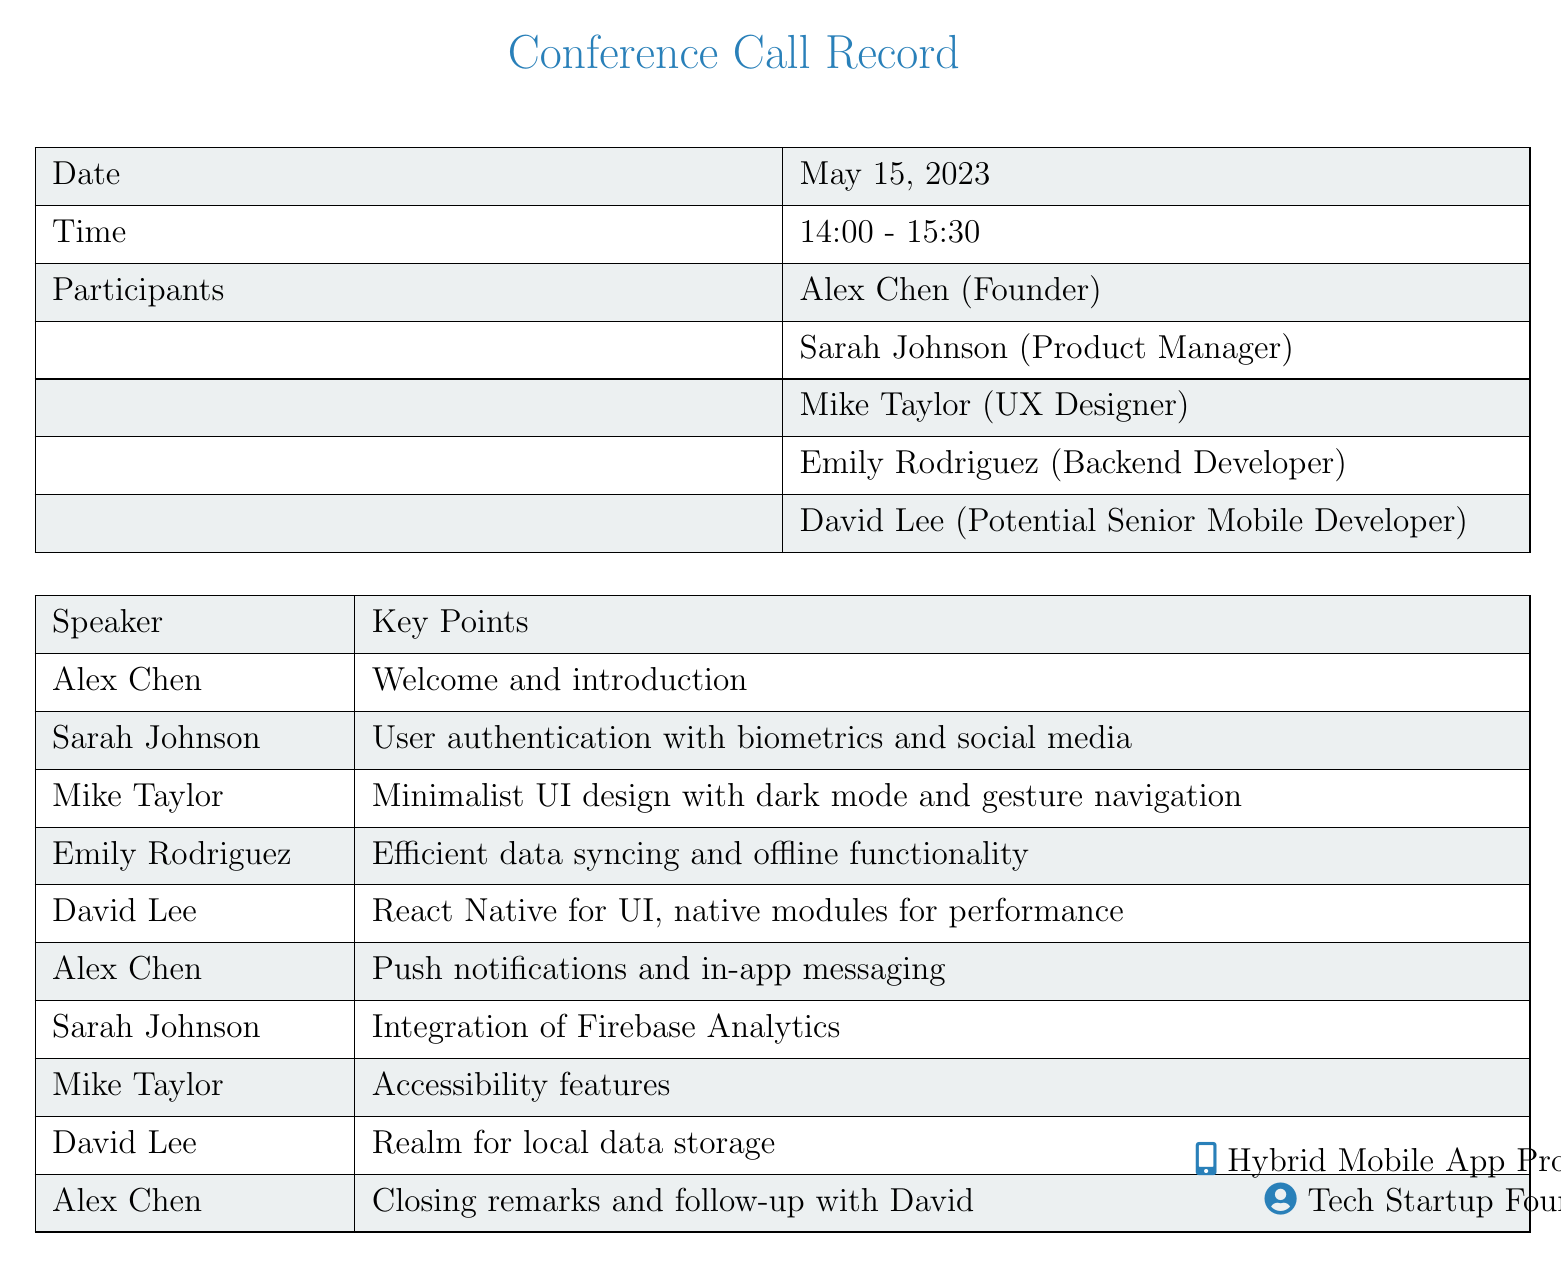What is the date of the conference call? The date is specified in the document as the date of the meeting.
Answer: May 15, 2023 Who is the Product Manager? The document lists the participants, identifying their roles, including the Product Manager.
Answer: Sarah Johnson What feature did Sarah Johnson suggest? The document includes key points made by participants, indicating features discussed during the call.
Answer: User authentication with biometrics and social media What technology did David Lee recommend for UI development? The document states David Lee's input on technology to be used, particularly for UI.
Answer: React Native What was mentioned for local data storage? One of the key points includes a specific technology recommended for local data.
Answer: Realm Who provided the closing remarks? The document indicates who concluded the discussion during the call.
Answer: Alex Chen What time did the conference call start? The starting time of the conference call is indicated in the document.
Answer: 14:00 Which participant is a Potential Senior Mobile Developer? The document identifies participants along with their roles.
Answer: David Lee What functionality did Emily Rodriguez emphasize? The key points in the document include a suggestion made by Emily Rodriguez.
Answer: Efficient data syncing and offline functionality 